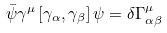Convert formula to latex. <formula><loc_0><loc_0><loc_500><loc_500>\bar { \psi } \gamma ^ { \mu } \left [ \gamma _ { \alpha } , \gamma _ { \beta } \right ] \psi = \delta \Gamma _ { \alpha \beta } ^ { \mu }</formula> 